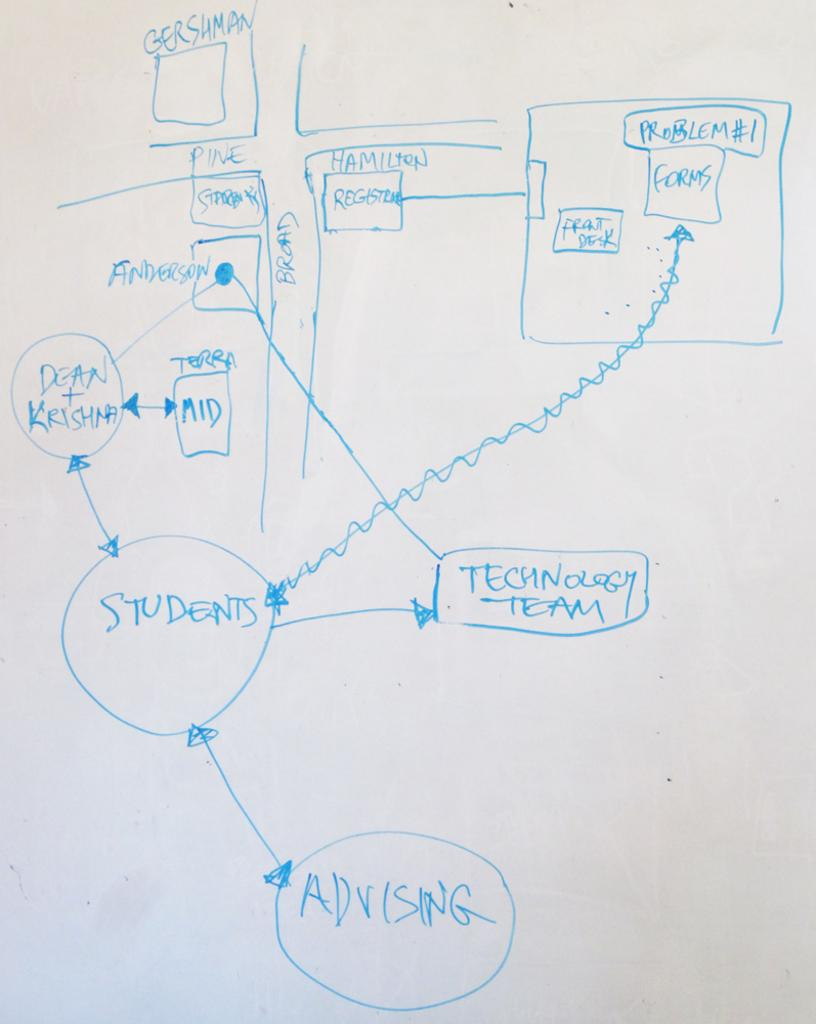<image>
Give a short and clear explanation of the subsequent image. A diagram that shows students relationship with advising and the technology team. 